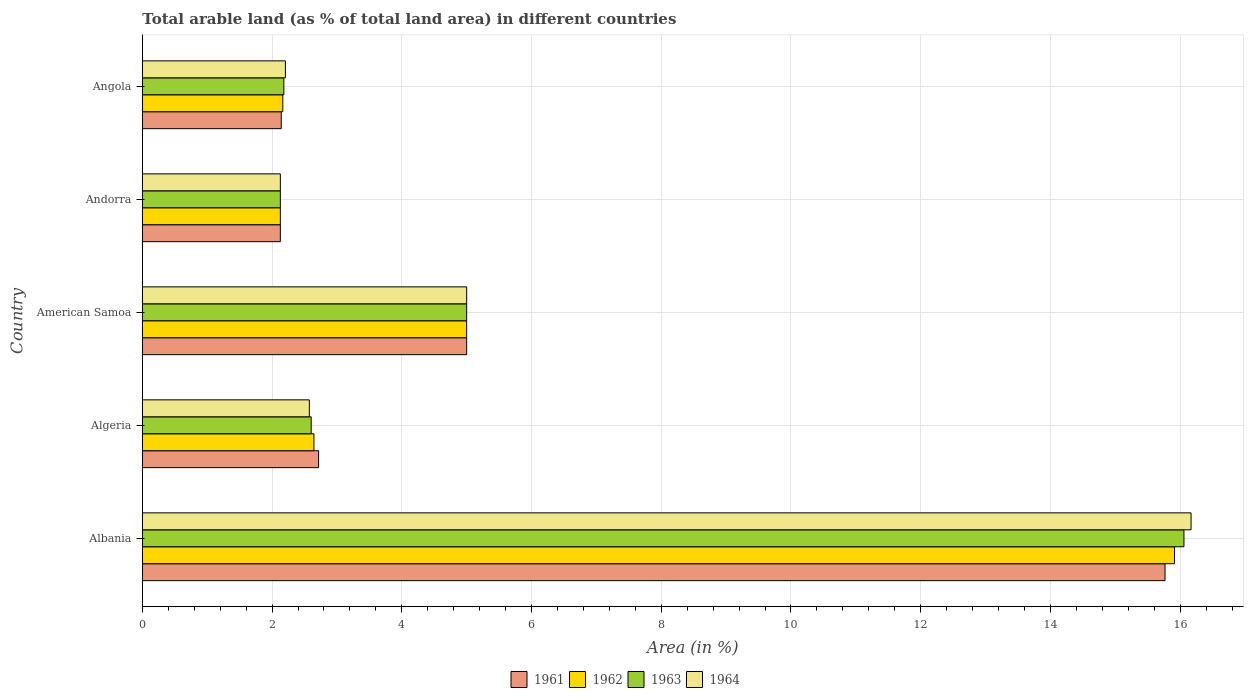How many different coloured bars are there?
Your answer should be compact. 4. Are the number of bars per tick equal to the number of legend labels?
Give a very brief answer. Yes. Are the number of bars on each tick of the Y-axis equal?
Offer a very short reply. Yes. How many bars are there on the 3rd tick from the top?
Ensure brevity in your answer.  4. What is the label of the 4th group of bars from the top?
Your answer should be compact. Algeria. What is the percentage of arable land in 1962 in Albania?
Offer a very short reply. 15.91. Across all countries, what is the maximum percentage of arable land in 1962?
Provide a succinct answer. 15.91. Across all countries, what is the minimum percentage of arable land in 1964?
Make the answer very short. 2.13. In which country was the percentage of arable land in 1962 maximum?
Offer a terse response. Albania. In which country was the percentage of arable land in 1962 minimum?
Your answer should be very brief. Andorra. What is the total percentage of arable land in 1964 in the graph?
Your response must be concise. 28.08. What is the difference between the percentage of arable land in 1961 in Albania and that in American Samoa?
Keep it short and to the point. 10.77. What is the difference between the percentage of arable land in 1963 in Albania and the percentage of arable land in 1962 in Angola?
Offer a terse response. 13.89. What is the average percentage of arable land in 1963 per country?
Provide a succinct answer. 5.59. What is the difference between the percentage of arable land in 1962 and percentage of arable land in 1964 in Albania?
Your response must be concise. -0.26. What is the ratio of the percentage of arable land in 1961 in American Samoa to that in Angola?
Your response must be concise. 2.33. What is the difference between the highest and the second highest percentage of arable land in 1964?
Offer a terse response. 11.17. What is the difference between the highest and the lowest percentage of arable land in 1962?
Provide a succinct answer. 13.78. Is the sum of the percentage of arable land in 1963 in Albania and Andorra greater than the maximum percentage of arable land in 1964 across all countries?
Give a very brief answer. Yes. What does the 4th bar from the top in Andorra represents?
Keep it short and to the point. 1961. What does the 1st bar from the bottom in Algeria represents?
Your response must be concise. 1961. Is it the case that in every country, the sum of the percentage of arable land in 1962 and percentage of arable land in 1964 is greater than the percentage of arable land in 1961?
Give a very brief answer. Yes. How many bars are there?
Give a very brief answer. 20. Are all the bars in the graph horizontal?
Provide a succinct answer. Yes. What is the difference between two consecutive major ticks on the X-axis?
Your response must be concise. 2. Does the graph contain grids?
Make the answer very short. Yes. How many legend labels are there?
Offer a terse response. 4. How are the legend labels stacked?
Give a very brief answer. Horizontal. What is the title of the graph?
Ensure brevity in your answer.  Total arable land (as % of total land area) in different countries. Does "1982" appear as one of the legend labels in the graph?
Your answer should be compact. No. What is the label or title of the X-axis?
Offer a very short reply. Area (in %). What is the Area (in %) of 1961 in Albania?
Make the answer very short. 15.77. What is the Area (in %) of 1962 in Albania?
Give a very brief answer. 15.91. What is the Area (in %) of 1963 in Albania?
Offer a terse response. 16.06. What is the Area (in %) in 1964 in Albania?
Offer a very short reply. 16.17. What is the Area (in %) of 1961 in Algeria?
Provide a short and direct response. 2.72. What is the Area (in %) in 1962 in Algeria?
Provide a succinct answer. 2.65. What is the Area (in %) of 1963 in Algeria?
Provide a succinct answer. 2.6. What is the Area (in %) of 1964 in Algeria?
Your response must be concise. 2.57. What is the Area (in %) of 1961 in American Samoa?
Your answer should be compact. 5. What is the Area (in %) in 1961 in Andorra?
Offer a very short reply. 2.13. What is the Area (in %) in 1962 in Andorra?
Keep it short and to the point. 2.13. What is the Area (in %) of 1963 in Andorra?
Offer a very short reply. 2.13. What is the Area (in %) in 1964 in Andorra?
Provide a succinct answer. 2.13. What is the Area (in %) in 1961 in Angola?
Offer a very short reply. 2.14. What is the Area (in %) of 1962 in Angola?
Offer a terse response. 2.17. What is the Area (in %) of 1963 in Angola?
Give a very brief answer. 2.18. What is the Area (in %) of 1964 in Angola?
Your answer should be very brief. 2.21. Across all countries, what is the maximum Area (in %) of 1961?
Make the answer very short. 15.77. Across all countries, what is the maximum Area (in %) in 1962?
Offer a terse response. 15.91. Across all countries, what is the maximum Area (in %) of 1963?
Ensure brevity in your answer.  16.06. Across all countries, what is the maximum Area (in %) in 1964?
Offer a terse response. 16.17. Across all countries, what is the minimum Area (in %) of 1961?
Keep it short and to the point. 2.13. Across all countries, what is the minimum Area (in %) in 1962?
Make the answer very short. 2.13. Across all countries, what is the minimum Area (in %) in 1963?
Give a very brief answer. 2.13. Across all countries, what is the minimum Area (in %) in 1964?
Keep it short and to the point. 2.13. What is the total Area (in %) of 1961 in the graph?
Provide a short and direct response. 27.75. What is the total Area (in %) of 1962 in the graph?
Provide a succinct answer. 27.85. What is the total Area (in %) of 1963 in the graph?
Provide a short and direct response. 27.97. What is the total Area (in %) of 1964 in the graph?
Your answer should be very brief. 28.08. What is the difference between the Area (in %) of 1961 in Albania and that in Algeria?
Keep it short and to the point. 13.05. What is the difference between the Area (in %) of 1962 in Albania and that in Algeria?
Make the answer very short. 13.27. What is the difference between the Area (in %) of 1963 in Albania and that in Algeria?
Give a very brief answer. 13.46. What is the difference between the Area (in %) of 1964 in Albania and that in Algeria?
Your answer should be very brief. 13.59. What is the difference between the Area (in %) of 1961 in Albania and that in American Samoa?
Make the answer very short. 10.77. What is the difference between the Area (in %) in 1962 in Albania and that in American Samoa?
Keep it short and to the point. 10.91. What is the difference between the Area (in %) in 1963 in Albania and that in American Samoa?
Provide a short and direct response. 11.06. What is the difference between the Area (in %) in 1964 in Albania and that in American Samoa?
Your answer should be very brief. 11.17. What is the difference between the Area (in %) of 1961 in Albania and that in Andorra?
Make the answer very short. 13.64. What is the difference between the Area (in %) in 1962 in Albania and that in Andorra?
Give a very brief answer. 13.78. What is the difference between the Area (in %) of 1963 in Albania and that in Andorra?
Provide a succinct answer. 13.93. What is the difference between the Area (in %) in 1964 in Albania and that in Andorra?
Your answer should be very brief. 14.04. What is the difference between the Area (in %) in 1961 in Albania and that in Angola?
Provide a succinct answer. 13.62. What is the difference between the Area (in %) of 1962 in Albania and that in Angola?
Your answer should be compact. 13.75. What is the difference between the Area (in %) in 1963 in Albania and that in Angola?
Ensure brevity in your answer.  13.88. What is the difference between the Area (in %) in 1964 in Albania and that in Angola?
Provide a succinct answer. 13.96. What is the difference between the Area (in %) of 1961 in Algeria and that in American Samoa?
Your answer should be compact. -2.28. What is the difference between the Area (in %) of 1962 in Algeria and that in American Samoa?
Provide a short and direct response. -2.35. What is the difference between the Area (in %) of 1963 in Algeria and that in American Samoa?
Provide a succinct answer. -2.4. What is the difference between the Area (in %) in 1964 in Algeria and that in American Samoa?
Keep it short and to the point. -2.43. What is the difference between the Area (in %) in 1961 in Algeria and that in Andorra?
Provide a short and direct response. 0.59. What is the difference between the Area (in %) of 1962 in Algeria and that in Andorra?
Give a very brief answer. 0.52. What is the difference between the Area (in %) in 1963 in Algeria and that in Andorra?
Offer a very short reply. 0.48. What is the difference between the Area (in %) in 1964 in Algeria and that in Andorra?
Ensure brevity in your answer.  0.45. What is the difference between the Area (in %) in 1961 in Algeria and that in Angola?
Your response must be concise. 0.58. What is the difference between the Area (in %) in 1962 in Algeria and that in Angola?
Make the answer very short. 0.48. What is the difference between the Area (in %) in 1963 in Algeria and that in Angola?
Make the answer very short. 0.42. What is the difference between the Area (in %) of 1964 in Algeria and that in Angola?
Provide a succinct answer. 0.37. What is the difference between the Area (in %) in 1961 in American Samoa and that in Andorra?
Make the answer very short. 2.87. What is the difference between the Area (in %) in 1962 in American Samoa and that in Andorra?
Your answer should be compact. 2.87. What is the difference between the Area (in %) of 1963 in American Samoa and that in Andorra?
Keep it short and to the point. 2.87. What is the difference between the Area (in %) in 1964 in American Samoa and that in Andorra?
Your response must be concise. 2.87. What is the difference between the Area (in %) of 1961 in American Samoa and that in Angola?
Give a very brief answer. 2.86. What is the difference between the Area (in %) of 1962 in American Samoa and that in Angola?
Your answer should be very brief. 2.83. What is the difference between the Area (in %) of 1963 in American Samoa and that in Angola?
Offer a terse response. 2.82. What is the difference between the Area (in %) of 1964 in American Samoa and that in Angola?
Your response must be concise. 2.79. What is the difference between the Area (in %) of 1961 in Andorra and that in Angola?
Make the answer very short. -0.01. What is the difference between the Area (in %) in 1962 in Andorra and that in Angola?
Keep it short and to the point. -0.04. What is the difference between the Area (in %) of 1963 in Andorra and that in Angola?
Your response must be concise. -0.05. What is the difference between the Area (in %) in 1964 in Andorra and that in Angola?
Your answer should be compact. -0.08. What is the difference between the Area (in %) in 1961 in Albania and the Area (in %) in 1962 in Algeria?
Keep it short and to the point. 13.12. What is the difference between the Area (in %) of 1961 in Albania and the Area (in %) of 1963 in Algeria?
Give a very brief answer. 13.16. What is the difference between the Area (in %) of 1961 in Albania and the Area (in %) of 1964 in Algeria?
Ensure brevity in your answer.  13.19. What is the difference between the Area (in %) in 1962 in Albania and the Area (in %) in 1963 in Algeria?
Your response must be concise. 13.31. What is the difference between the Area (in %) in 1962 in Albania and the Area (in %) in 1964 in Algeria?
Provide a succinct answer. 13.34. What is the difference between the Area (in %) of 1963 in Albania and the Area (in %) of 1964 in Algeria?
Ensure brevity in your answer.  13.48. What is the difference between the Area (in %) in 1961 in Albania and the Area (in %) in 1962 in American Samoa?
Ensure brevity in your answer.  10.77. What is the difference between the Area (in %) of 1961 in Albania and the Area (in %) of 1963 in American Samoa?
Provide a short and direct response. 10.77. What is the difference between the Area (in %) of 1961 in Albania and the Area (in %) of 1964 in American Samoa?
Your response must be concise. 10.77. What is the difference between the Area (in %) in 1962 in Albania and the Area (in %) in 1963 in American Samoa?
Offer a terse response. 10.91. What is the difference between the Area (in %) in 1962 in Albania and the Area (in %) in 1964 in American Samoa?
Provide a succinct answer. 10.91. What is the difference between the Area (in %) in 1963 in Albania and the Area (in %) in 1964 in American Samoa?
Provide a short and direct response. 11.06. What is the difference between the Area (in %) of 1961 in Albania and the Area (in %) of 1962 in Andorra?
Provide a succinct answer. 13.64. What is the difference between the Area (in %) of 1961 in Albania and the Area (in %) of 1963 in Andorra?
Keep it short and to the point. 13.64. What is the difference between the Area (in %) in 1961 in Albania and the Area (in %) in 1964 in Andorra?
Your answer should be compact. 13.64. What is the difference between the Area (in %) in 1962 in Albania and the Area (in %) in 1963 in Andorra?
Give a very brief answer. 13.78. What is the difference between the Area (in %) in 1962 in Albania and the Area (in %) in 1964 in Andorra?
Ensure brevity in your answer.  13.78. What is the difference between the Area (in %) of 1963 in Albania and the Area (in %) of 1964 in Andorra?
Your answer should be compact. 13.93. What is the difference between the Area (in %) of 1961 in Albania and the Area (in %) of 1962 in Angola?
Make the answer very short. 13.6. What is the difference between the Area (in %) in 1961 in Albania and the Area (in %) in 1963 in Angola?
Your answer should be compact. 13.58. What is the difference between the Area (in %) of 1961 in Albania and the Area (in %) of 1964 in Angola?
Give a very brief answer. 13.56. What is the difference between the Area (in %) of 1962 in Albania and the Area (in %) of 1963 in Angola?
Ensure brevity in your answer.  13.73. What is the difference between the Area (in %) in 1962 in Albania and the Area (in %) in 1964 in Angola?
Provide a short and direct response. 13.71. What is the difference between the Area (in %) in 1963 in Albania and the Area (in %) in 1964 in Angola?
Your answer should be very brief. 13.85. What is the difference between the Area (in %) of 1961 in Algeria and the Area (in %) of 1962 in American Samoa?
Your response must be concise. -2.28. What is the difference between the Area (in %) of 1961 in Algeria and the Area (in %) of 1963 in American Samoa?
Ensure brevity in your answer.  -2.28. What is the difference between the Area (in %) of 1961 in Algeria and the Area (in %) of 1964 in American Samoa?
Your answer should be compact. -2.28. What is the difference between the Area (in %) of 1962 in Algeria and the Area (in %) of 1963 in American Samoa?
Your response must be concise. -2.35. What is the difference between the Area (in %) of 1962 in Algeria and the Area (in %) of 1964 in American Samoa?
Make the answer very short. -2.35. What is the difference between the Area (in %) in 1963 in Algeria and the Area (in %) in 1964 in American Samoa?
Your answer should be very brief. -2.4. What is the difference between the Area (in %) of 1961 in Algeria and the Area (in %) of 1962 in Andorra?
Offer a terse response. 0.59. What is the difference between the Area (in %) of 1961 in Algeria and the Area (in %) of 1963 in Andorra?
Your response must be concise. 0.59. What is the difference between the Area (in %) of 1961 in Algeria and the Area (in %) of 1964 in Andorra?
Keep it short and to the point. 0.59. What is the difference between the Area (in %) of 1962 in Algeria and the Area (in %) of 1963 in Andorra?
Ensure brevity in your answer.  0.52. What is the difference between the Area (in %) in 1962 in Algeria and the Area (in %) in 1964 in Andorra?
Keep it short and to the point. 0.52. What is the difference between the Area (in %) in 1963 in Algeria and the Area (in %) in 1964 in Andorra?
Your answer should be very brief. 0.48. What is the difference between the Area (in %) in 1961 in Algeria and the Area (in %) in 1962 in Angola?
Provide a short and direct response. 0.55. What is the difference between the Area (in %) of 1961 in Algeria and the Area (in %) of 1963 in Angola?
Your answer should be very brief. 0.54. What is the difference between the Area (in %) of 1961 in Algeria and the Area (in %) of 1964 in Angola?
Offer a very short reply. 0.51. What is the difference between the Area (in %) of 1962 in Algeria and the Area (in %) of 1963 in Angola?
Offer a terse response. 0.46. What is the difference between the Area (in %) of 1962 in Algeria and the Area (in %) of 1964 in Angola?
Offer a terse response. 0.44. What is the difference between the Area (in %) in 1963 in Algeria and the Area (in %) in 1964 in Angola?
Make the answer very short. 0.4. What is the difference between the Area (in %) of 1961 in American Samoa and the Area (in %) of 1962 in Andorra?
Keep it short and to the point. 2.87. What is the difference between the Area (in %) of 1961 in American Samoa and the Area (in %) of 1963 in Andorra?
Keep it short and to the point. 2.87. What is the difference between the Area (in %) in 1961 in American Samoa and the Area (in %) in 1964 in Andorra?
Make the answer very short. 2.87. What is the difference between the Area (in %) in 1962 in American Samoa and the Area (in %) in 1963 in Andorra?
Give a very brief answer. 2.87. What is the difference between the Area (in %) of 1962 in American Samoa and the Area (in %) of 1964 in Andorra?
Give a very brief answer. 2.87. What is the difference between the Area (in %) in 1963 in American Samoa and the Area (in %) in 1964 in Andorra?
Offer a terse response. 2.87. What is the difference between the Area (in %) of 1961 in American Samoa and the Area (in %) of 1962 in Angola?
Your answer should be very brief. 2.83. What is the difference between the Area (in %) in 1961 in American Samoa and the Area (in %) in 1963 in Angola?
Offer a very short reply. 2.82. What is the difference between the Area (in %) in 1961 in American Samoa and the Area (in %) in 1964 in Angola?
Offer a terse response. 2.79. What is the difference between the Area (in %) of 1962 in American Samoa and the Area (in %) of 1963 in Angola?
Your answer should be compact. 2.82. What is the difference between the Area (in %) in 1962 in American Samoa and the Area (in %) in 1964 in Angola?
Provide a short and direct response. 2.79. What is the difference between the Area (in %) in 1963 in American Samoa and the Area (in %) in 1964 in Angola?
Make the answer very short. 2.79. What is the difference between the Area (in %) of 1961 in Andorra and the Area (in %) of 1962 in Angola?
Ensure brevity in your answer.  -0.04. What is the difference between the Area (in %) in 1961 in Andorra and the Area (in %) in 1963 in Angola?
Your response must be concise. -0.05. What is the difference between the Area (in %) in 1961 in Andorra and the Area (in %) in 1964 in Angola?
Provide a succinct answer. -0.08. What is the difference between the Area (in %) of 1962 in Andorra and the Area (in %) of 1963 in Angola?
Offer a very short reply. -0.05. What is the difference between the Area (in %) in 1962 in Andorra and the Area (in %) in 1964 in Angola?
Your response must be concise. -0.08. What is the difference between the Area (in %) of 1963 in Andorra and the Area (in %) of 1964 in Angola?
Make the answer very short. -0.08. What is the average Area (in %) in 1961 per country?
Your response must be concise. 5.55. What is the average Area (in %) of 1962 per country?
Offer a terse response. 5.57. What is the average Area (in %) in 1963 per country?
Provide a short and direct response. 5.59. What is the average Area (in %) in 1964 per country?
Offer a terse response. 5.62. What is the difference between the Area (in %) of 1961 and Area (in %) of 1962 in Albania?
Your response must be concise. -0.15. What is the difference between the Area (in %) in 1961 and Area (in %) in 1963 in Albania?
Your answer should be very brief. -0.29. What is the difference between the Area (in %) in 1961 and Area (in %) in 1964 in Albania?
Your answer should be very brief. -0.4. What is the difference between the Area (in %) in 1962 and Area (in %) in 1963 in Albania?
Give a very brief answer. -0.15. What is the difference between the Area (in %) of 1962 and Area (in %) of 1964 in Albania?
Provide a succinct answer. -0.26. What is the difference between the Area (in %) of 1963 and Area (in %) of 1964 in Albania?
Your answer should be compact. -0.11. What is the difference between the Area (in %) of 1961 and Area (in %) of 1962 in Algeria?
Your response must be concise. 0.07. What is the difference between the Area (in %) in 1961 and Area (in %) in 1963 in Algeria?
Your answer should be very brief. 0.11. What is the difference between the Area (in %) in 1961 and Area (in %) in 1964 in Algeria?
Keep it short and to the point. 0.14. What is the difference between the Area (in %) of 1962 and Area (in %) of 1963 in Algeria?
Your answer should be compact. 0.04. What is the difference between the Area (in %) in 1962 and Area (in %) in 1964 in Algeria?
Offer a terse response. 0.07. What is the difference between the Area (in %) in 1963 and Area (in %) in 1964 in Algeria?
Provide a short and direct response. 0.03. What is the difference between the Area (in %) of 1961 and Area (in %) of 1962 in American Samoa?
Make the answer very short. 0. What is the difference between the Area (in %) of 1961 and Area (in %) of 1964 in American Samoa?
Provide a short and direct response. 0. What is the difference between the Area (in %) of 1962 and Area (in %) of 1964 in American Samoa?
Give a very brief answer. 0. What is the difference between the Area (in %) of 1961 and Area (in %) of 1962 in Andorra?
Offer a terse response. 0. What is the difference between the Area (in %) in 1962 and Area (in %) in 1964 in Andorra?
Your answer should be very brief. 0. What is the difference between the Area (in %) of 1961 and Area (in %) of 1962 in Angola?
Offer a terse response. -0.02. What is the difference between the Area (in %) of 1961 and Area (in %) of 1963 in Angola?
Offer a terse response. -0.04. What is the difference between the Area (in %) in 1961 and Area (in %) in 1964 in Angola?
Your answer should be compact. -0.06. What is the difference between the Area (in %) of 1962 and Area (in %) of 1963 in Angola?
Provide a succinct answer. -0.02. What is the difference between the Area (in %) in 1962 and Area (in %) in 1964 in Angola?
Offer a terse response. -0.04. What is the difference between the Area (in %) in 1963 and Area (in %) in 1964 in Angola?
Ensure brevity in your answer.  -0.02. What is the ratio of the Area (in %) in 1961 in Albania to that in Algeria?
Provide a succinct answer. 5.8. What is the ratio of the Area (in %) of 1962 in Albania to that in Algeria?
Give a very brief answer. 6.02. What is the ratio of the Area (in %) of 1963 in Albania to that in Algeria?
Provide a short and direct response. 6.17. What is the ratio of the Area (in %) in 1964 in Albania to that in Algeria?
Give a very brief answer. 6.28. What is the ratio of the Area (in %) in 1961 in Albania to that in American Samoa?
Your response must be concise. 3.15. What is the ratio of the Area (in %) in 1962 in Albania to that in American Samoa?
Your answer should be very brief. 3.18. What is the ratio of the Area (in %) of 1963 in Albania to that in American Samoa?
Keep it short and to the point. 3.21. What is the ratio of the Area (in %) of 1964 in Albania to that in American Samoa?
Give a very brief answer. 3.23. What is the ratio of the Area (in %) of 1961 in Albania to that in Andorra?
Offer a terse response. 7.41. What is the ratio of the Area (in %) of 1962 in Albania to that in Andorra?
Your response must be concise. 7.48. What is the ratio of the Area (in %) of 1963 in Albania to that in Andorra?
Provide a succinct answer. 7.55. What is the ratio of the Area (in %) in 1964 in Albania to that in Andorra?
Offer a very short reply. 7.6. What is the ratio of the Area (in %) in 1961 in Albania to that in Angola?
Provide a succinct answer. 7.36. What is the ratio of the Area (in %) of 1962 in Albania to that in Angola?
Provide a short and direct response. 7.35. What is the ratio of the Area (in %) of 1963 in Albania to that in Angola?
Your answer should be very brief. 7.36. What is the ratio of the Area (in %) of 1964 in Albania to that in Angola?
Provide a succinct answer. 7.33. What is the ratio of the Area (in %) of 1961 in Algeria to that in American Samoa?
Provide a succinct answer. 0.54. What is the ratio of the Area (in %) of 1962 in Algeria to that in American Samoa?
Offer a terse response. 0.53. What is the ratio of the Area (in %) in 1963 in Algeria to that in American Samoa?
Your answer should be very brief. 0.52. What is the ratio of the Area (in %) of 1964 in Algeria to that in American Samoa?
Offer a terse response. 0.51. What is the ratio of the Area (in %) in 1961 in Algeria to that in Andorra?
Your answer should be compact. 1.28. What is the ratio of the Area (in %) of 1962 in Algeria to that in Andorra?
Your answer should be compact. 1.24. What is the ratio of the Area (in %) in 1963 in Algeria to that in Andorra?
Your answer should be very brief. 1.22. What is the ratio of the Area (in %) of 1964 in Algeria to that in Andorra?
Your answer should be compact. 1.21. What is the ratio of the Area (in %) of 1961 in Algeria to that in Angola?
Your answer should be very brief. 1.27. What is the ratio of the Area (in %) in 1962 in Algeria to that in Angola?
Make the answer very short. 1.22. What is the ratio of the Area (in %) in 1963 in Algeria to that in Angola?
Offer a very short reply. 1.19. What is the ratio of the Area (in %) of 1964 in Algeria to that in Angola?
Make the answer very short. 1.17. What is the ratio of the Area (in %) in 1961 in American Samoa to that in Andorra?
Your answer should be very brief. 2.35. What is the ratio of the Area (in %) in 1962 in American Samoa to that in Andorra?
Keep it short and to the point. 2.35. What is the ratio of the Area (in %) of 1963 in American Samoa to that in Andorra?
Offer a very short reply. 2.35. What is the ratio of the Area (in %) of 1964 in American Samoa to that in Andorra?
Your answer should be compact. 2.35. What is the ratio of the Area (in %) of 1961 in American Samoa to that in Angola?
Your answer should be compact. 2.33. What is the ratio of the Area (in %) in 1962 in American Samoa to that in Angola?
Keep it short and to the point. 2.31. What is the ratio of the Area (in %) of 1963 in American Samoa to that in Angola?
Provide a succinct answer. 2.29. What is the ratio of the Area (in %) in 1964 in American Samoa to that in Angola?
Keep it short and to the point. 2.27. What is the ratio of the Area (in %) in 1962 in Andorra to that in Angola?
Provide a short and direct response. 0.98. What is the ratio of the Area (in %) in 1963 in Andorra to that in Angola?
Provide a short and direct response. 0.98. What is the ratio of the Area (in %) in 1964 in Andorra to that in Angola?
Offer a very short reply. 0.96. What is the difference between the highest and the second highest Area (in %) in 1961?
Your answer should be very brief. 10.77. What is the difference between the highest and the second highest Area (in %) in 1962?
Your answer should be very brief. 10.91. What is the difference between the highest and the second highest Area (in %) in 1963?
Your response must be concise. 11.06. What is the difference between the highest and the second highest Area (in %) of 1964?
Offer a terse response. 11.17. What is the difference between the highest and the lowest Area (in %) of 1961?
Your response must be concise. 13.64. What is the difference between the highest and the lowest Area (in %) of 1962?
Your answer should be very brief. 13.78. What is the difference between the highest and the lowest Area (in %) in 1963?
Make the answer very short. 13.93. What is the difference between the highest and the lowest Area (in %) in 1964?
Your response must be concise. 14.04. 